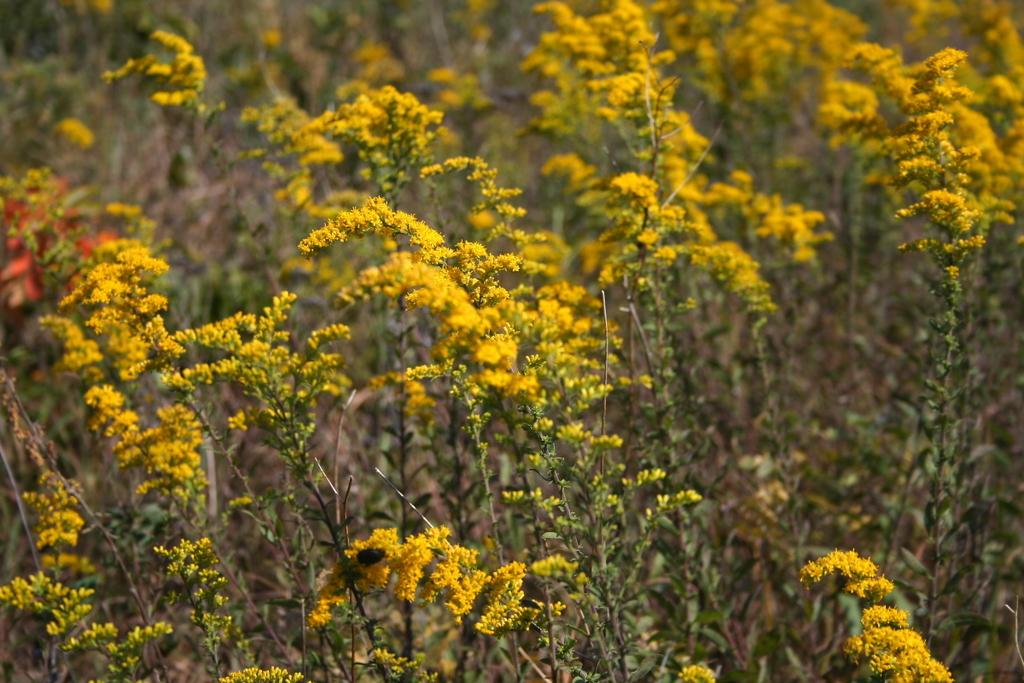What type of living organisms can be seen in the image? Plants can be seen in the image. What specific feature of the plants is visible? The plants have flowers. What color are the flowers? The flowers are yellow. Can you describe the background of the image? The background of the image is blurred. Where might this image have been taken? The image might have been taken in a garden. What type of songs can be heard coming from the flowers in the image? There are no songs coming from the flowers in the image, as flowers do not produce sound. 